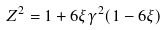Convert formula to latex. <formula><loc_0><loc_0><loc_500><loc_500>Z ^ { 2 } = 1 + 6 \xi \gamma ^ { 2 } ( 1 - 6 \xi )</formula> 